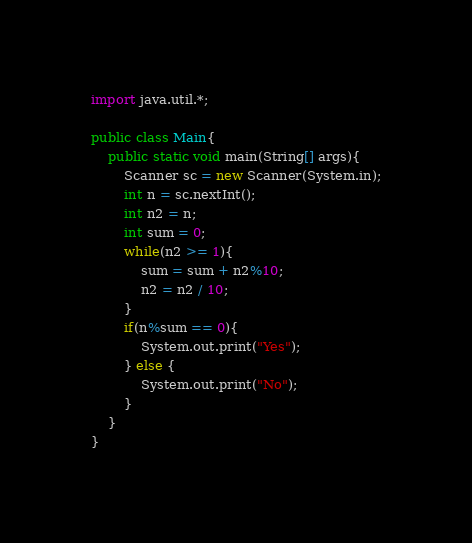Convert code to text. <code><loc_0><loc_0><loc_500><loc_500><_Java_>import java.util.*;

public class Main{
    public static void main(String[] args){
        Scanner sc = new Scanner(System.in);
        int n = sc.nextInt();
        int n2 = n;
        int sum = 0;
        while(n2 >= 1){
            sum = sum + n2%10;
            n2 = n2 / 10;
        }
        if(n%sum == 0){
            System.out.print("Yes");
        } else {
            System.out.print("No");
        }
    }
}</code> 